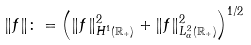<formula> <loc_0><loc_0><loc_500><loc_500>\| f \| \colon = \left ( \| f \| _ { H ^ { 1 } ( \mathbb { R } _ { + } ) } ^ { 2 } + \| f \| _ { L _ { \alpha } ^ { 2 } ( \mathbb { R } _ { + } ) } ^ { 2 } \right ) ^ { 1 / 2 }</formula> 